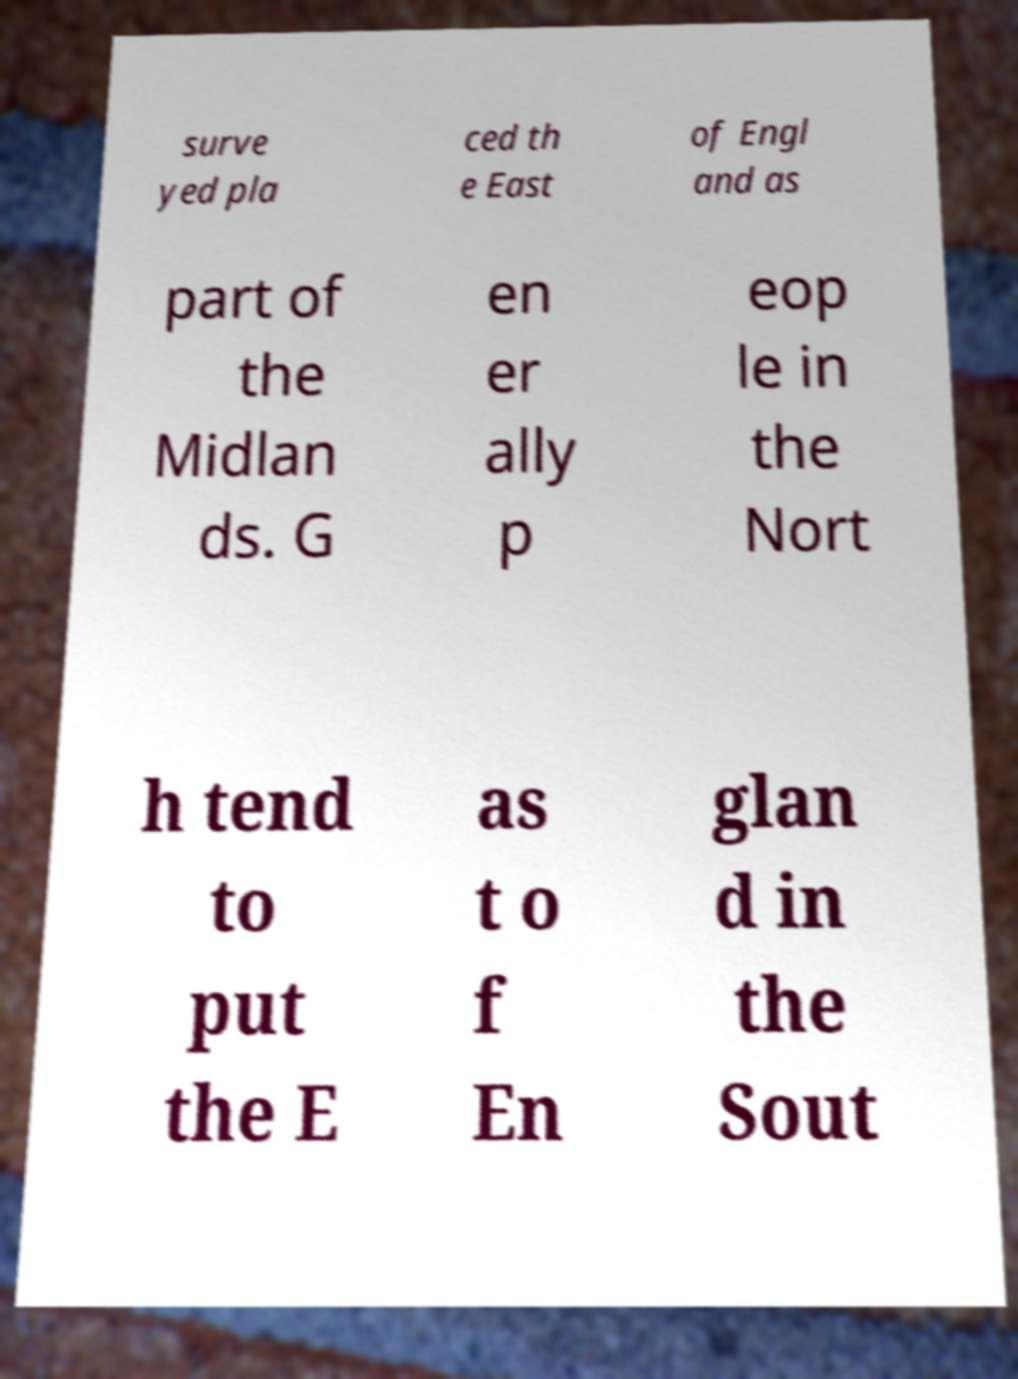Can you accurately transcribe the text from the provided image for me? surve yed pla ced th e East of Engl and as part of the Midlan ds. G en er ally p eop le in the Nort h tend to put the E as t o f En glan d in the Sout 